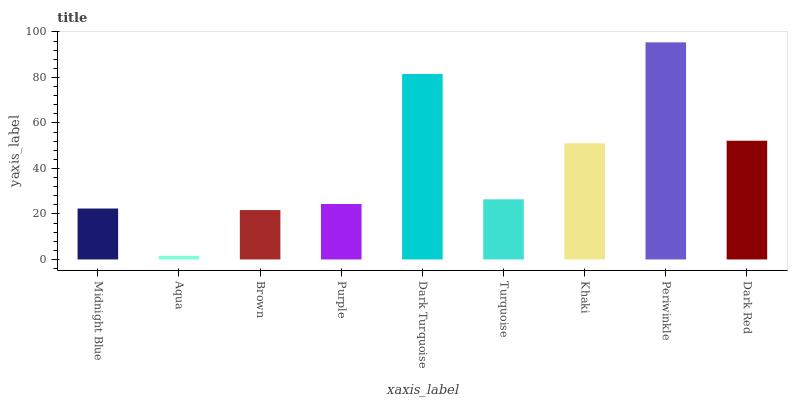Is Aqua the minimum?
Answer yes or no. Yes. Is Periwinkle the maximum?
Answer yes or no. Yes. Is Brown the minimum?
Answer yes or no. No. Is Brown the maximum?
Answer yes or no. No. Is Brown greater than Aqua?
Answer yes or no. Yes. Is Aqua less than Brown?
Answer yes or no. Yes. Is Aqua greater than Brown?
Answer yes or no. No. Is Brown less than Aqua?
Answer yes or no. No. Is Turquoise the high median?
Answer yes or no. Yes. Is Turquoise the low median?
Answer yes or no. Yes. Is Purple the high median?
Answer yes or no. No. Is Aqua the low median?
Answer yes or no. No. 